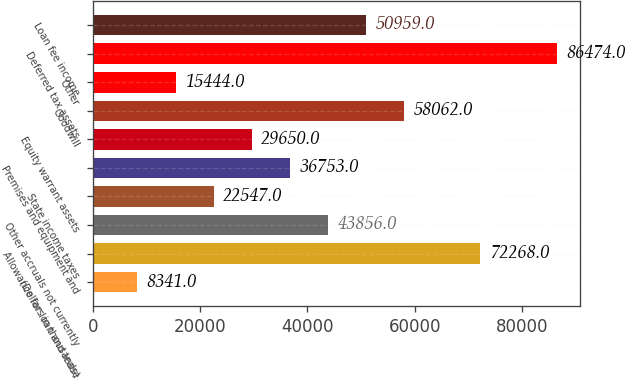<chart> <loc_0><loc_0><loc_500><loc_500><bar_chart><fcel>(Dollars in thousands)<fcel>Allowance for loan and lease<fcel>Other accruals not currently<fcel>State income taxes<fcel>Premises and equipment and<fcel>Equity warrant assets<fcel>Goodwill<fcel>Other<fcel>Deferred tax assets<fcel>Loan fee income<nl><fcel>8341<fcel>72268<fcel>43856<fcel>22547<fcel>36753<fcel>29650<fcel>58062<fcel>15444<fcel>86474<fcel>50959<nl></chart> 